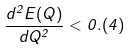Convert formula to latex. <formula><loc_0><loc_0><loc_500><loc_500>\frac { d ^ { 2 } E ( Q ) } { d Q ^ { 2 } } < 0 . ( 4 )</formula> 